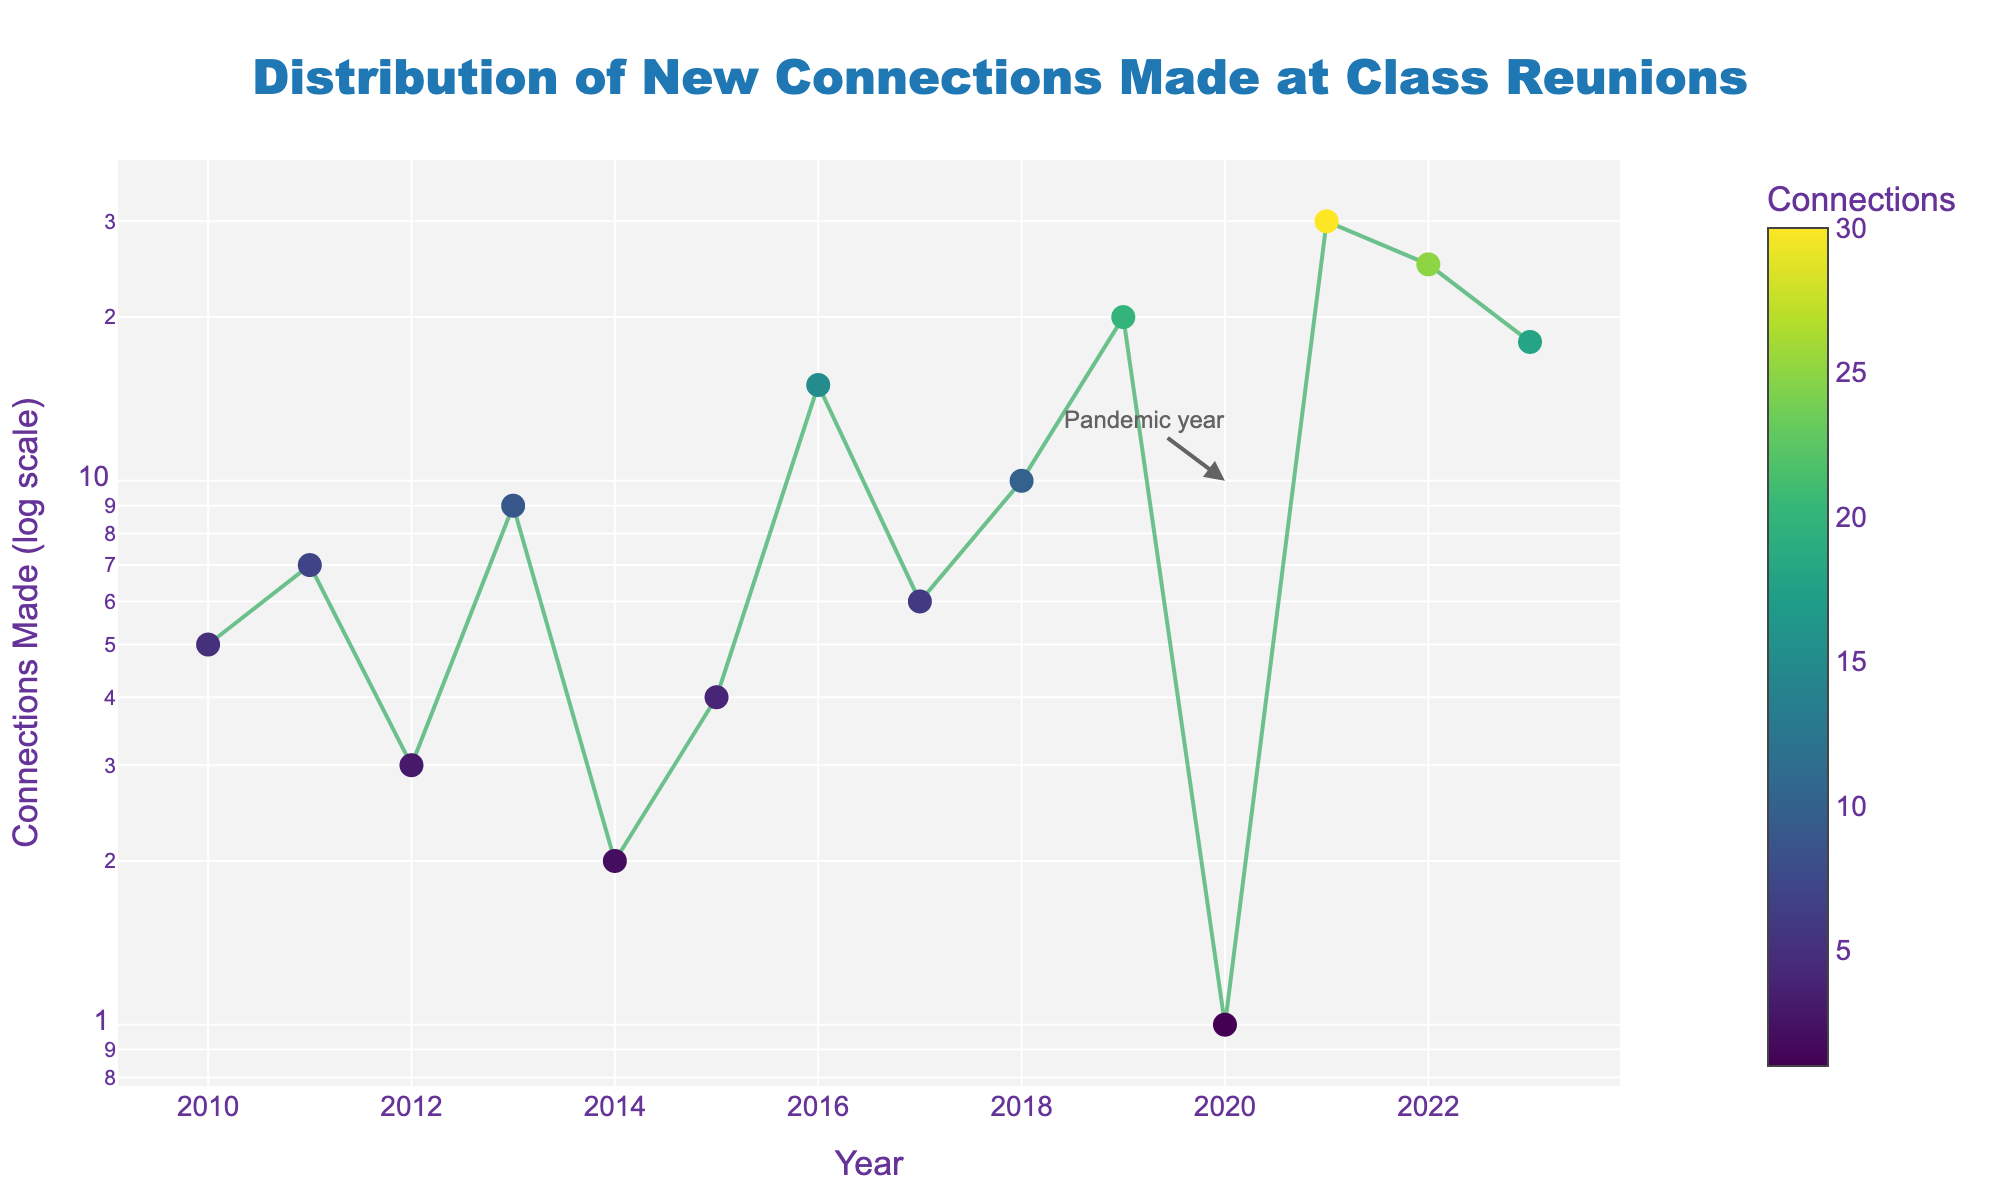What is the title of the figure? The title is located at the top and centered in the figure and reads "Distribution of New Connections Made at Class Reunions".
Answer: Distribution of New Connections Made at Class Reunions What is the y-axis label? The y-axis label is located on the left side of the graph and indicates the scale and unit used, which is: "Connections Made (log scale)".
Answer: Connections Made (log scale) In which year was the lowest number of connections made? By observing the data points on the plot, the lowest number of connections made is in 2020. This is also highlighted with an annotation indicating the pandemic year.
Answer: 2020 How many years are covered in the plot? The x-axis represents the years covered in the plot, ranging from 2010 to 2023. To determine the number of years, count the data points or range limits.
Answer: 14 What is the trend in the number of connections made from 2018 to 2021? By following the data points from 2018 to 2021, we can see that the number of connections increases each year.
Answer: Increasing What color represents higher numbers of connections made? The colors on the scatter plot use a colorscale "Viridis", where higher numbers of connections are indicated with colors closer to yellow.
Answer: Yellow Which year had significantly more connections than the previous year? Observing the year-to-year changes, 2021 shows a significant increase in connections compared to 2020, as the number jumps from 1 to 30.
Answer: 2021 Calculate the average number of connections made from 2010 to 2023. Sum the connections made from 2010 to 2023 and divide by the number of years (14). So, (5 + 7 + 3 + 9 + 2 + 4 + 15 + 6 + 10 + 20 + 1 + 30 + 25 + 18)/14 = 10.07.
Answer: 10.07 Which year had the most connections made? By observing the highest data point on the scatter plot, 2021 had the largest number of connections made at 30.
Answer: 2021 How does the number of connections made in 2016 compare to 2017? Comparing the data points for 2016 and 2017, 2016 had 15 connections whereas 2017 had 6 connections.
Answer: 2016 had more 